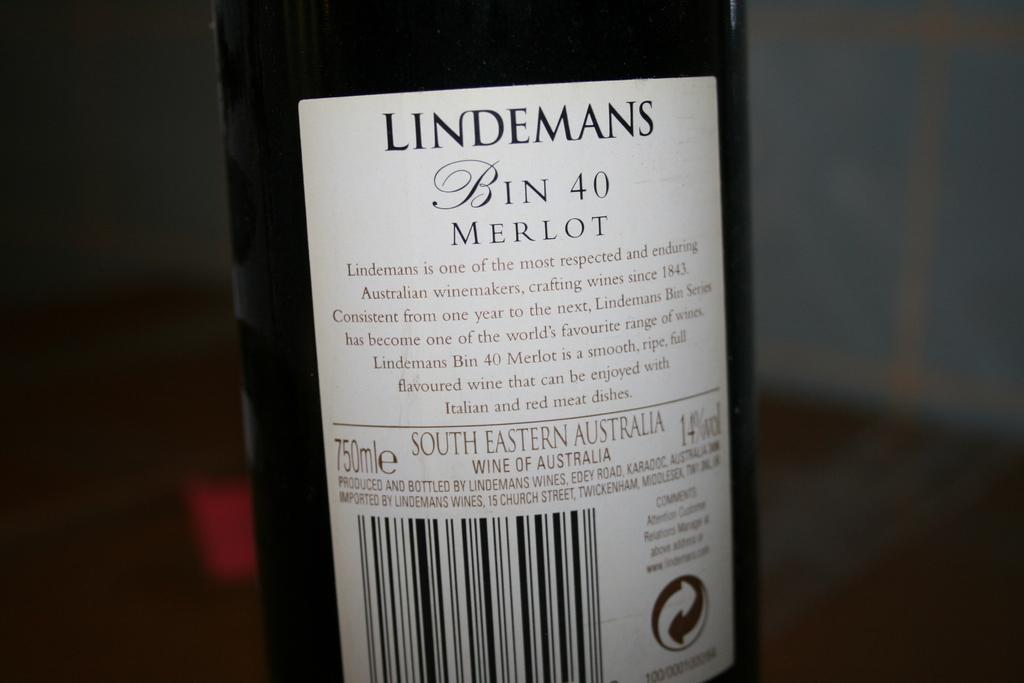<image>
Share a concise interpretation of the image provided. A bottle of Merlot had the brand name Lindemans on it. 